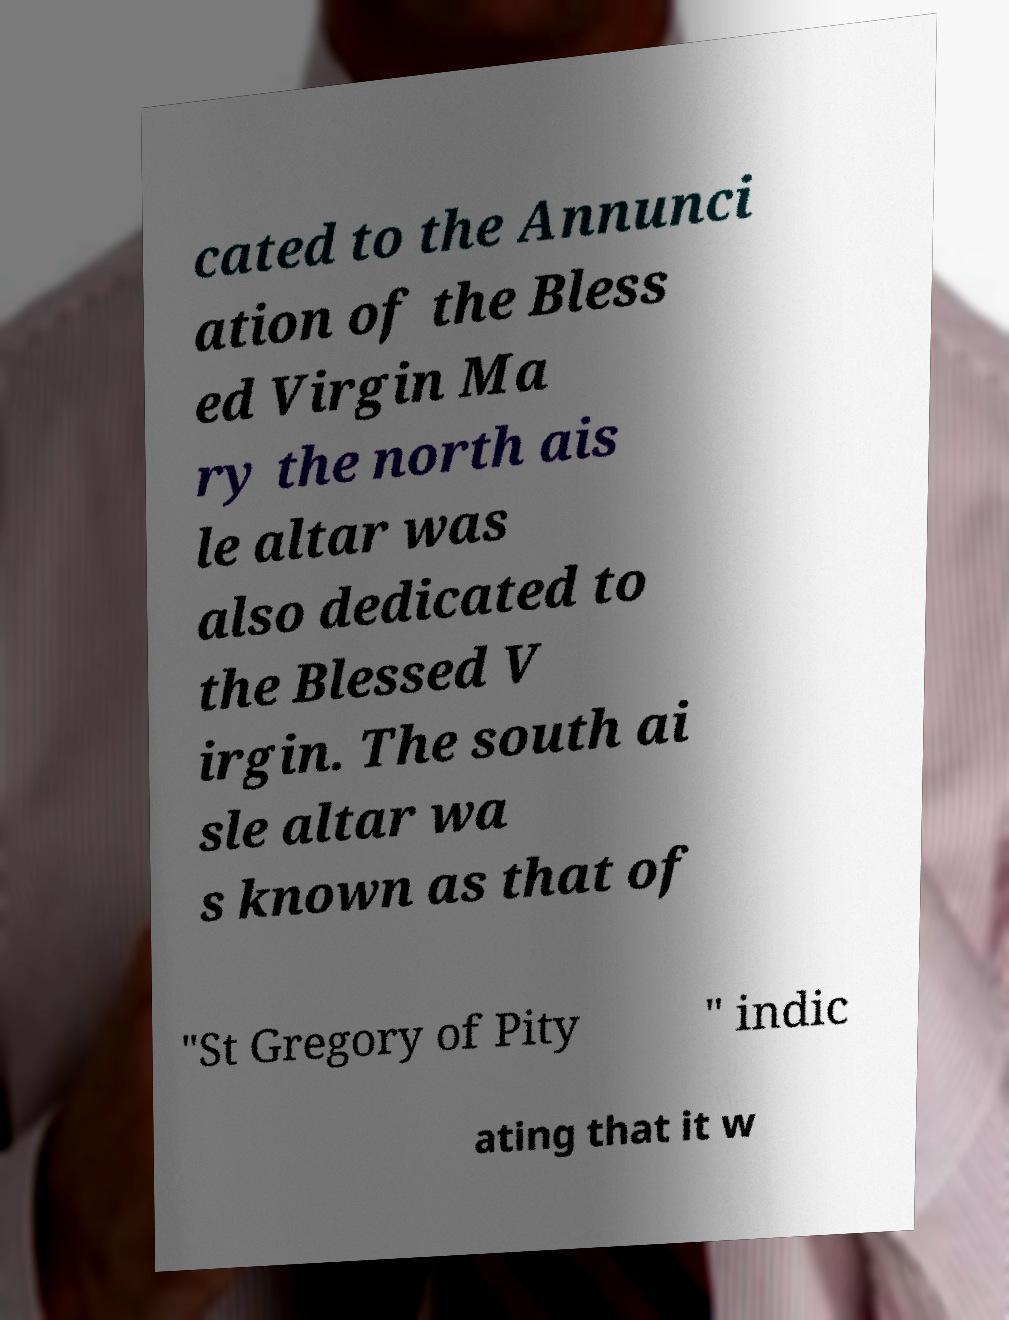I need the written content from this picture converted into text. Can you do that? cated to the Annunci ation of the Bless ed Virgin Ma ry the north ais le altar was also dedicated to the Blessed V irgin. The south ai sle altar wa s known as that of "St Gregory of Pity " indic ating that it w 